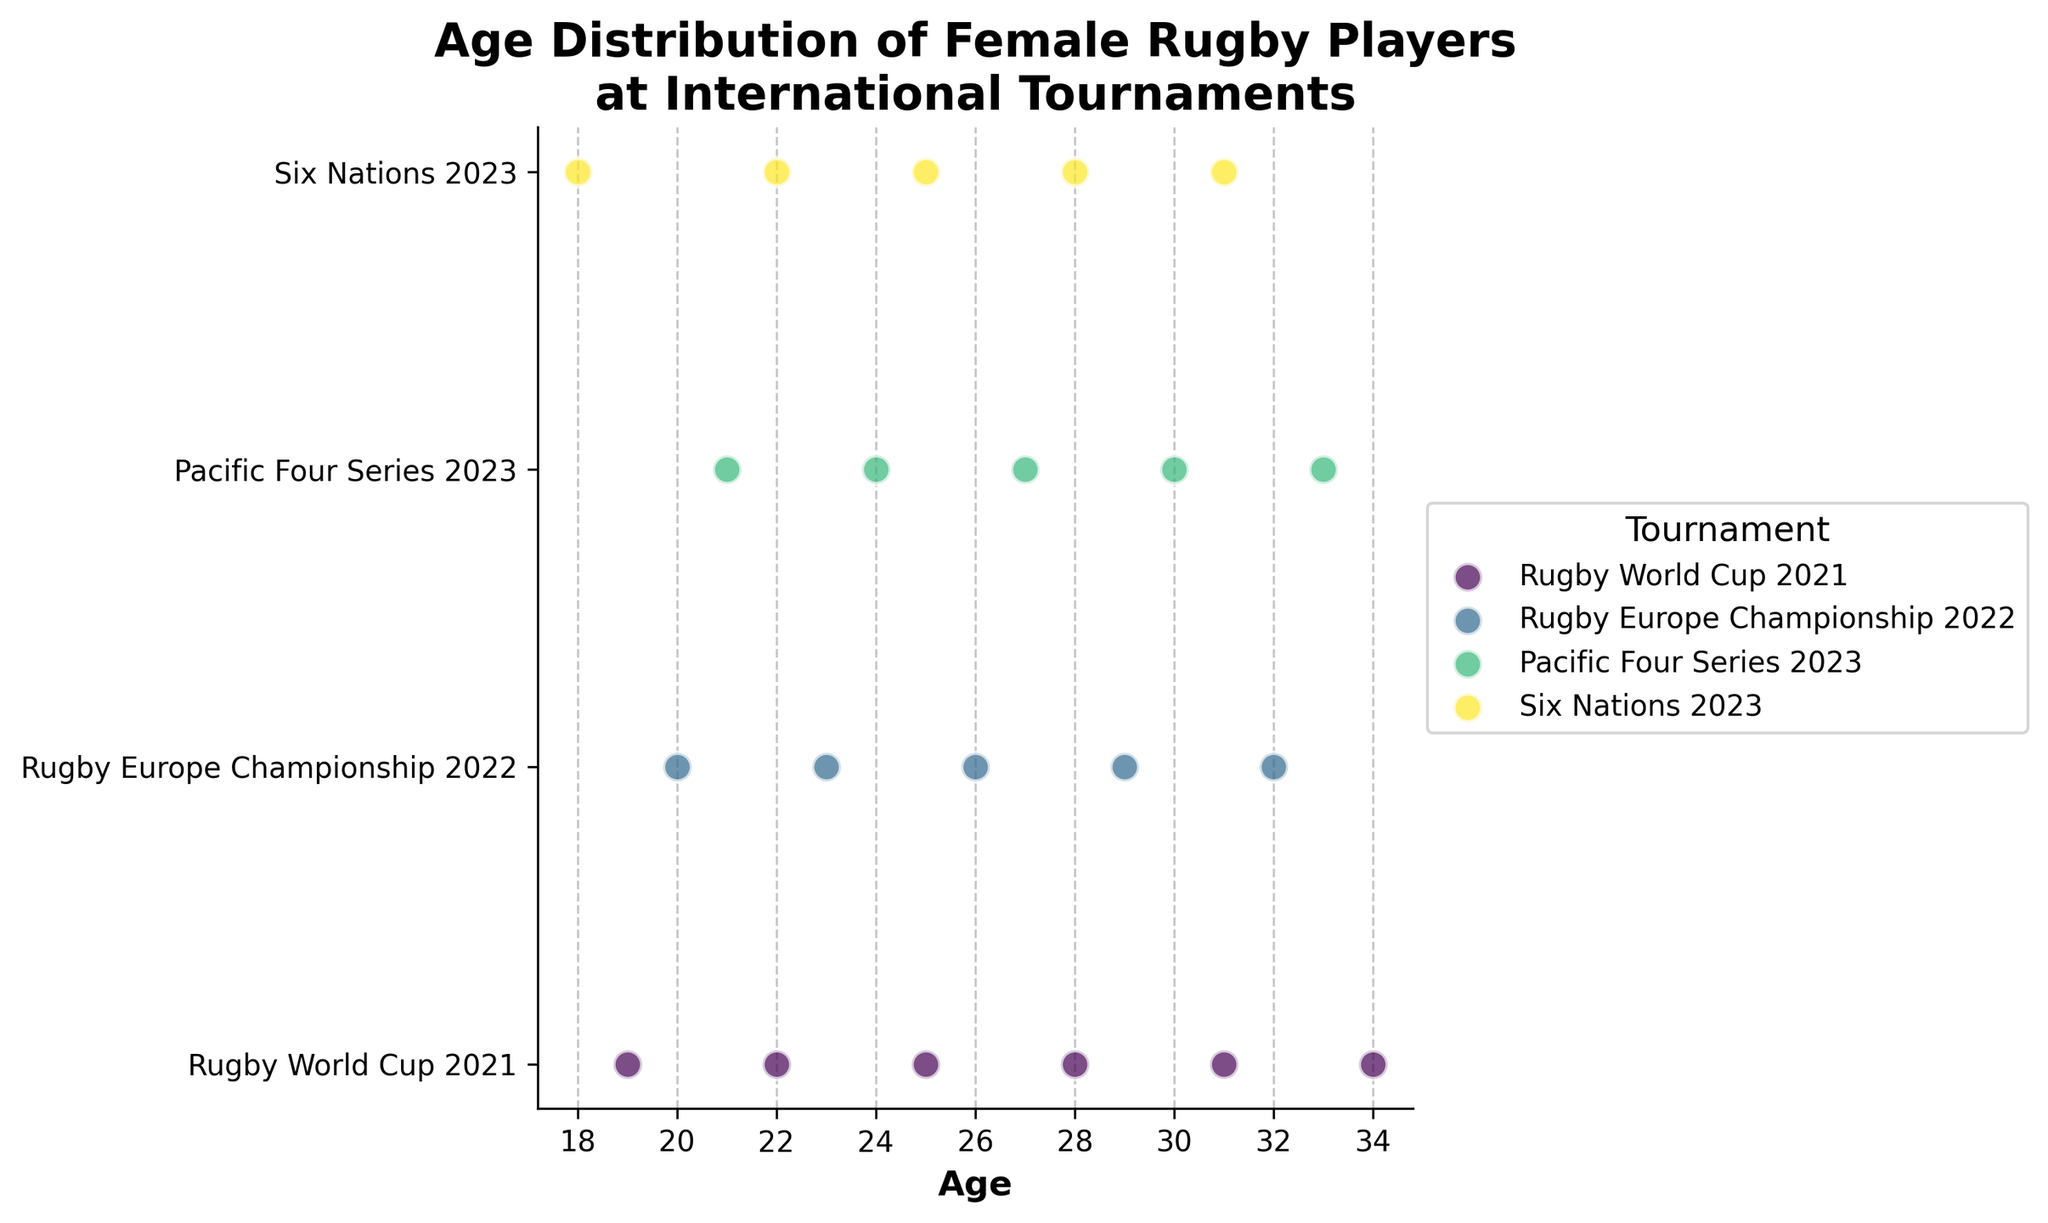What is the title of the plot? The title is usually displayed at the top of the plot. In this case, it reads "Age Distribution of Female Rugby Players at International Tournaments".
Answer: Age Distribution of Female Rugby Players at International Tournaments Which axis represents the age of the rugby players? The x-axis generally represents the continuous variable in a strip plot, which in this case is labeled "Age".
Answer: x-axis How many different tournaments are represented in the plot? The y-axis labels indicate the different tournaments. By counting them, we can see that there are four unique tournaments.
Answer: Four Which tournament has the youngest player, and what is her age? The youngest player's age is 18, represented on the graph by the leftmost data point. This point is aligned with the "Six Nations 2023" label.
Answer: Six Nations 2023, 18 In which tournament are the players aged 22 participating? By tracking the vertical lines from the data point at age 22, we see that these points align with both "Rugby World Cup 2021" and "Six Nations 2023".
Answer: Rugby World Cup 2021 and Six Nations 2023 What is the highest age of a player in the "Pacific Four Series 2023"? The highest age data point aligned with the "Pacific Four Series 2023" y-axis label is 33.
Answer: 33 How does the range of ages compare between the "Rugby Europe Championship 2022" and the "Pacific Four Series 2023"? The age range is the difference between the maximum and minimum ages. For "Rugby Europe Championship 2022", the range is 32 - 20 = 12. For "Pacific Four Series 2023", the range is 33 - 21 = 12. The ranges are equal.
Answer: Equal What is the median age of players in the "Rugby World Cup 2021"? The ages of the players in "Rugby World Cup 2021" are 19, 22, 25, 28, 31, and 34. The median is the middle number in a sorted list. In this case, (25 + 28)/2 = 26.5 since there are six numbers.
Answer: 26.5 Are there any tournaments where the players' ages span exactly one decade? By observing the ranges from the plot, we see that the "Six Nations 2023" spans from 18 to 31, which is more than a decade, while "Rugby Europe Championship 2022" spans from 20 to 32, "Pacific Four Series 2023" spans from 21 to 33, and "Rugby World Cup 2021" spans from 19 to 34. None of these span exactly one decade.
Answer: No What is the average age of players in the "Six Nations 2023"? The ages for "Six Nations 2023" are 18, 22, 25, 28, and 31. The sum of these ages is 124. Dividing by the number of players (5) gives the average: 124/5 = 24.8.
Answer: 24.8 